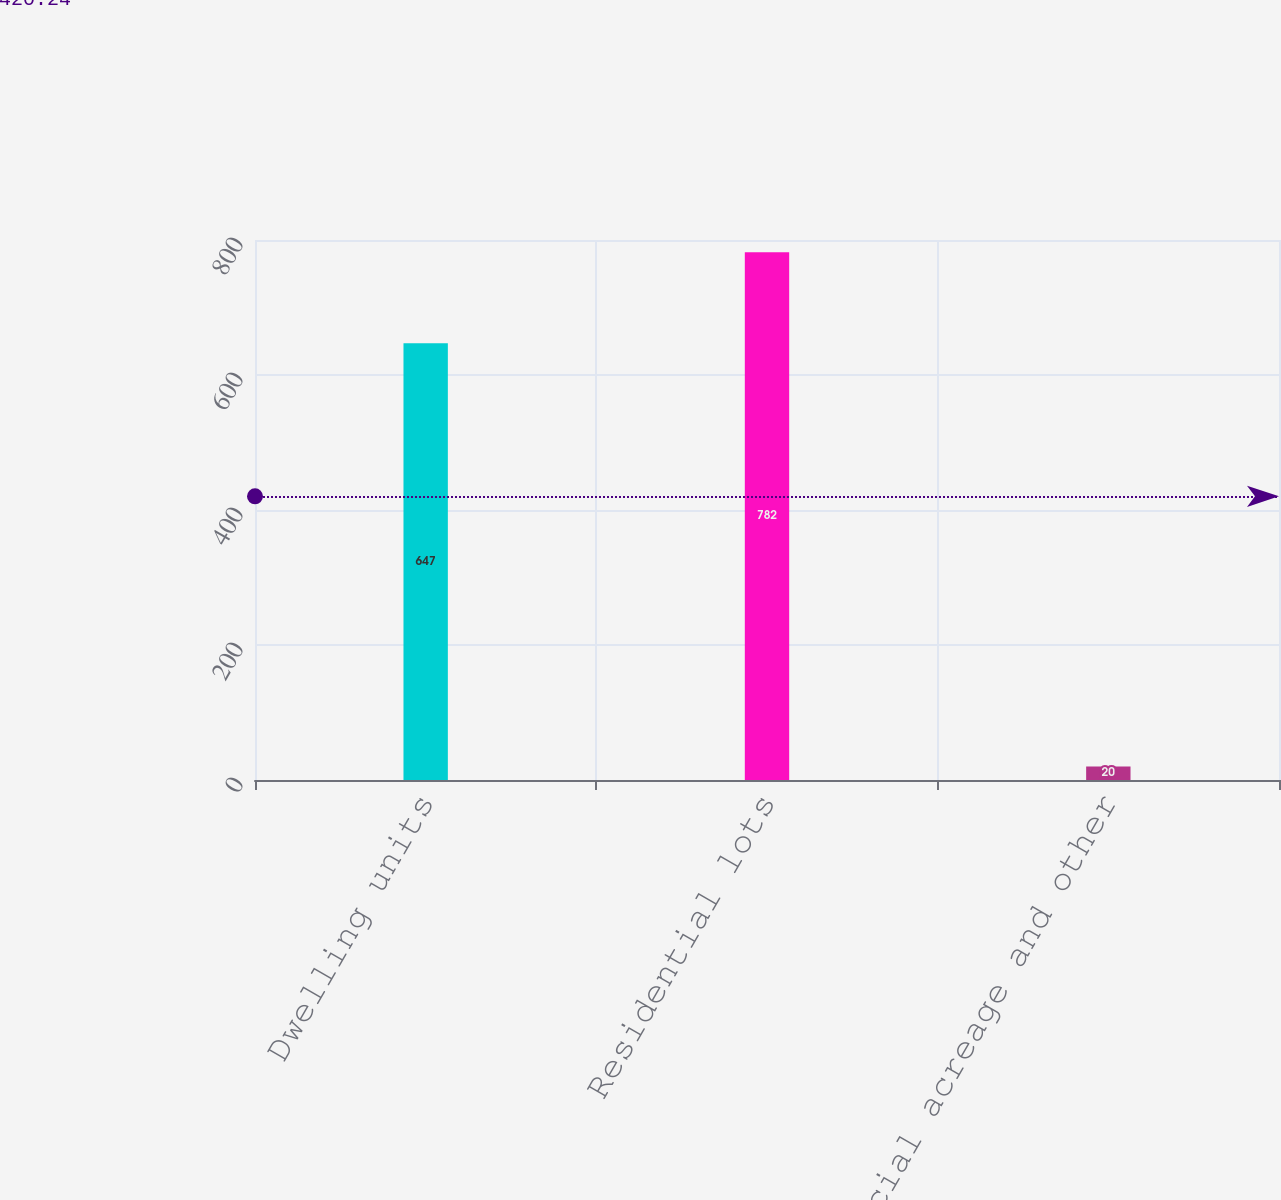Convert chart to OTSL. <chart><loc_0><loc_0><loc_500><loc_500><bar_chart><fcel>Dwelling units<fcel>Residential lots<fcel>Commercial acreage and other<nl><fcel>647<fcel>782<fcel>20<nl></chart> 